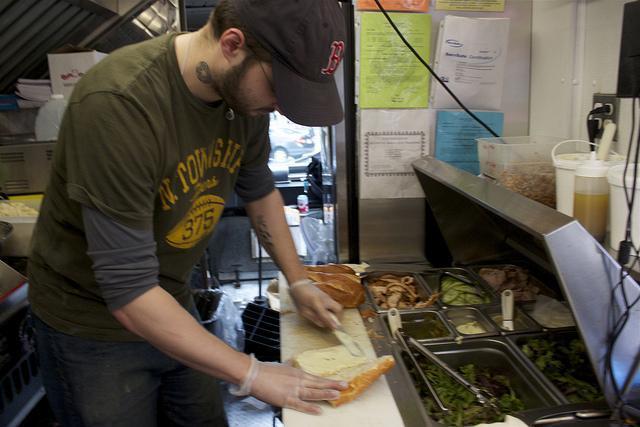Does the caption "The broccoli is touching the person." correctly depict the image?
Answer yes or no. No. 